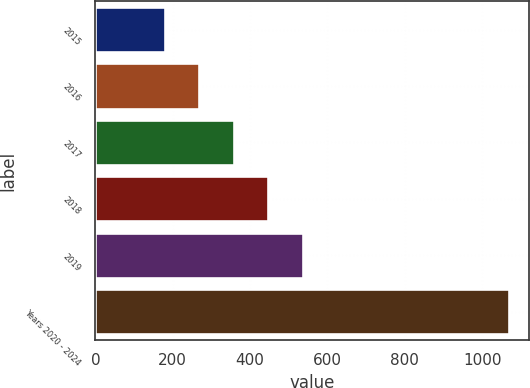<chart> <loc_0><loc_0><loc_500><loc_500><bar_chart><fcel>2015<fcel>2016<fcel>2017<fcel>2018<fcel>2019<fcel>Years 2020 - 2024<nl><fcel>180<fcel>268.9<fcel>357.8<fcel>446.7<fcel>535.6<fcel>1069<nl></chart> 